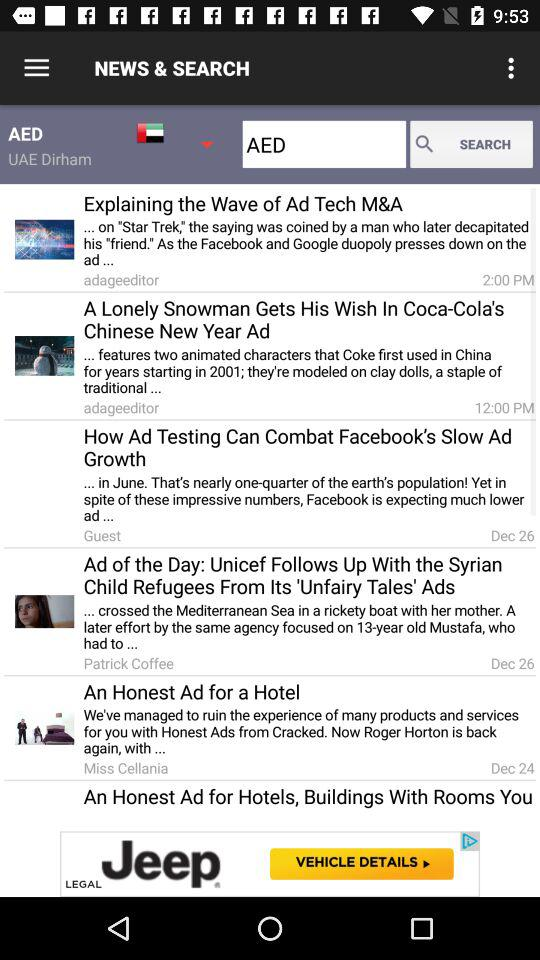What is the search keyword used in the search text box? The search keyword used in the search text box is AED. 